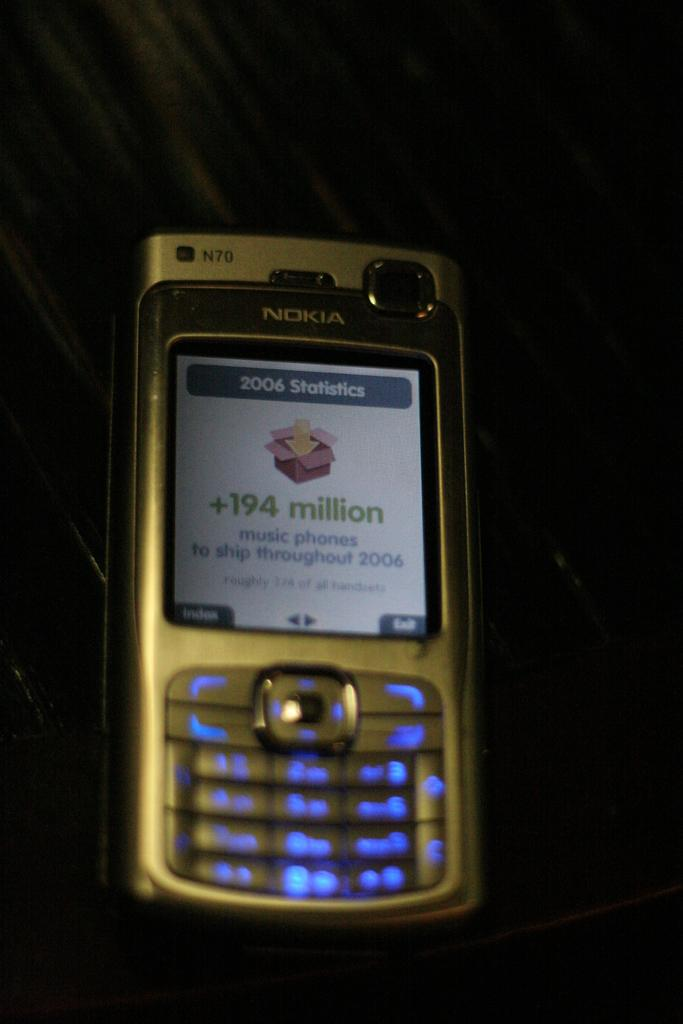<image>
Offer a succinct explanation of the picture presented. A Nokia cellphone with the screen lit, showing some statistics from 2006. 